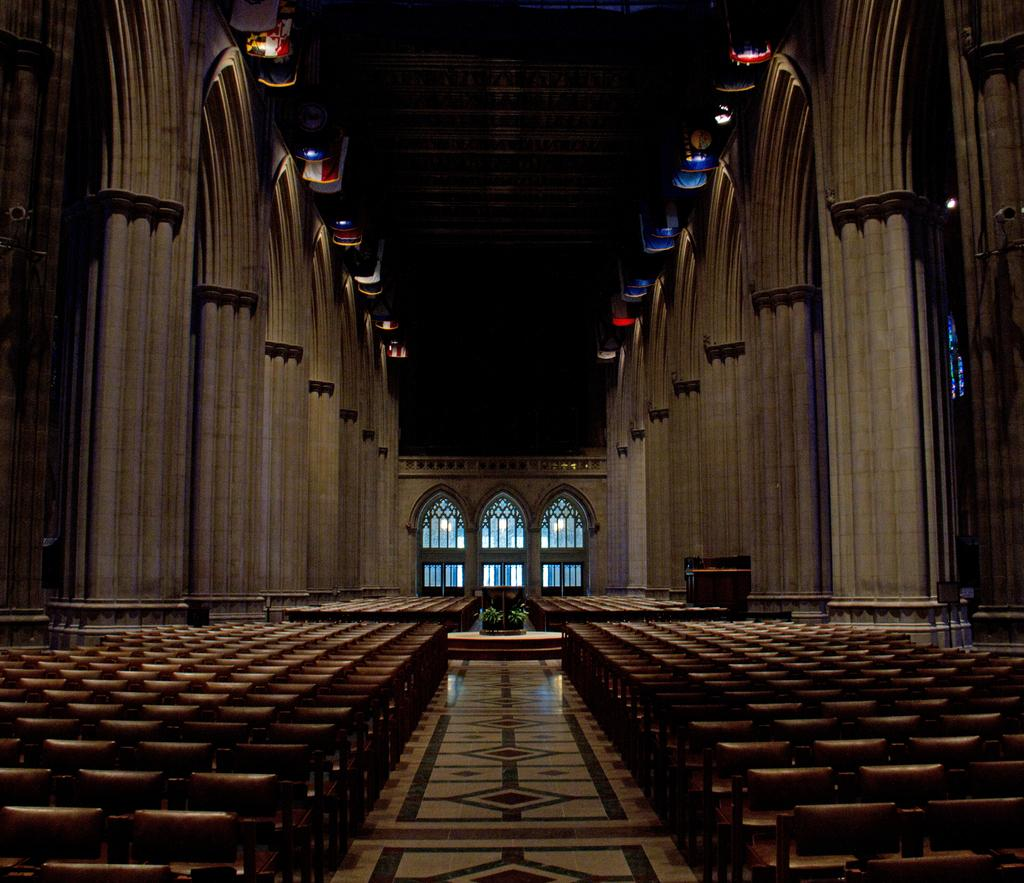What type of location is depicted in the image? The image is an inside view of a building. What architectural features can be seen in the image? There are pillars and a wall visible in the image. What elements are present for illumination in the image? There are lights in the image. How can people enter or exit the space in the image? There is a door in the image. What type of furniture is present in the image? There are chairs in the image. What is the surface that people walk on in the image? There is a floor in the image. What is used for amplifying sound in the image? There are speakers in the image. What structure is visible at the top of the image? There is a roof visible at the top of the image. How does the division wave in the image? There is no division wave present in the image. 